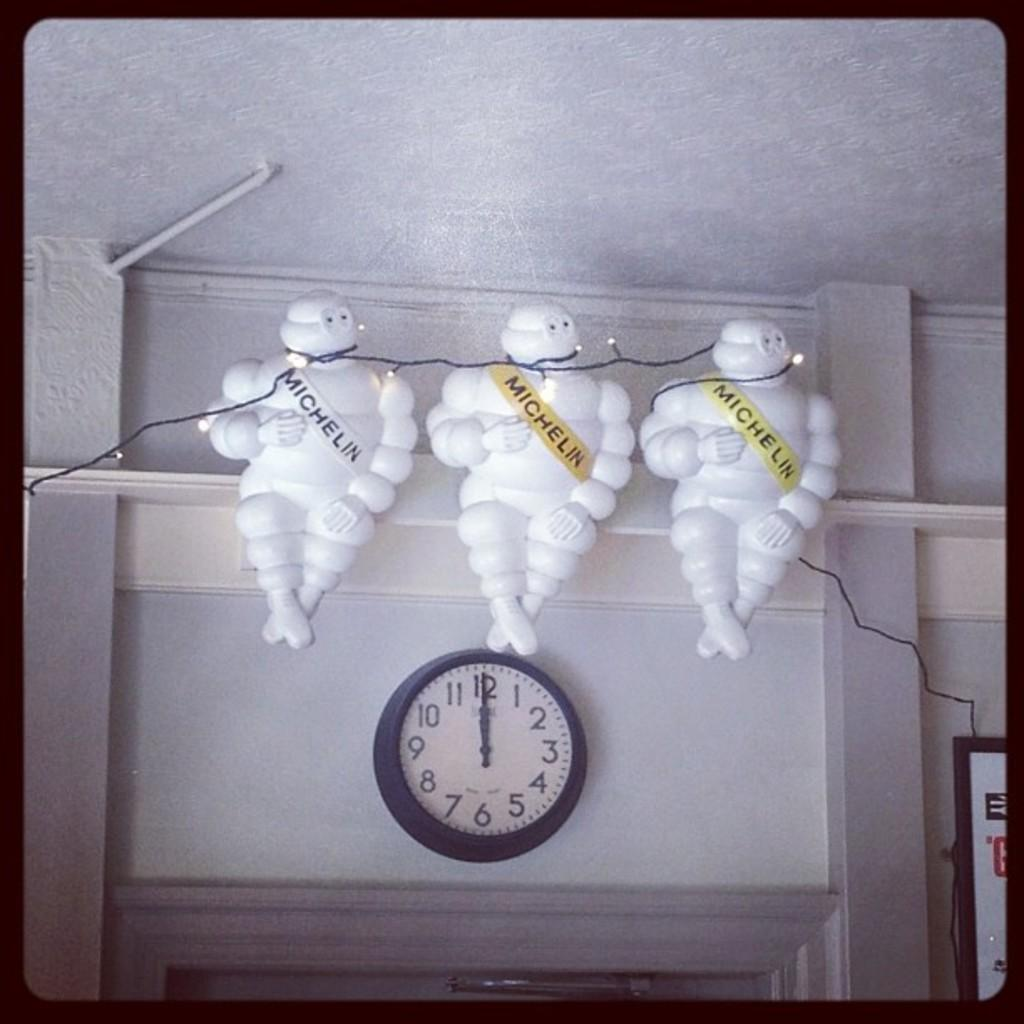<image>
Describe the image concisely. the number 12 that is on a clock 